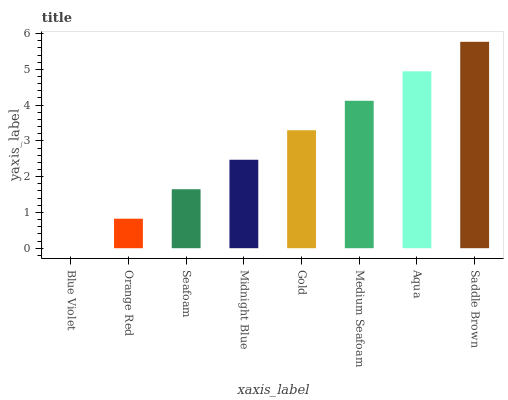Is Orange Red the minimum?
Answer yes or no. No. Is Orange Red the maximum?
Answer yes or no. No. Is Orange Red greater than Blue Violet?
Answer yes or no. Yes. Is Blue Violet less than Orange Red?
Answer yes or no. Yes. Is Blue Violet greater than Orange Red?
Answer yes or no. No. Is Orange Red less than Blue Violet?
Answer yes or no. No. Is Gold the high median?
Answer yes or no. Yes. Is Midnight Blue the low median?
Answer yes or no. Yes. Is Medium Seafoam the high median?
Answer yes or no. No. Is Saddle Brown the low median?
Answer yes or no. No. 